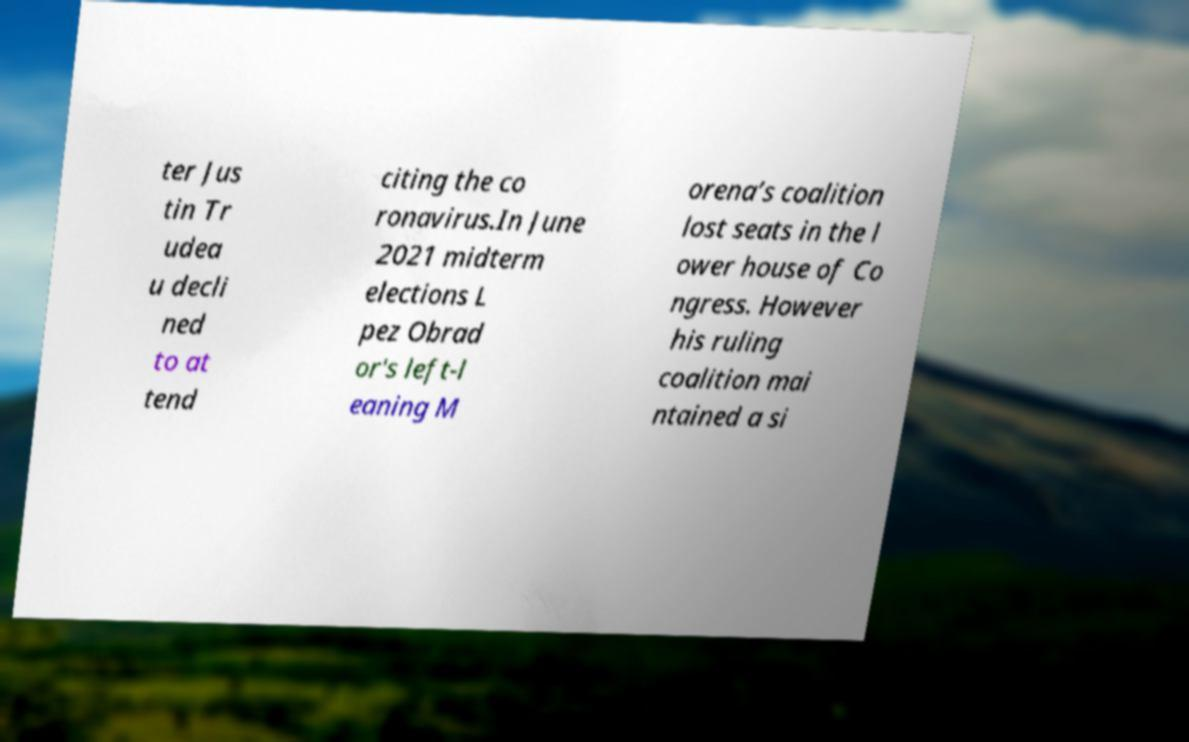For documentation purposes, I need the text within this image transcribed. Could you provide that? ter Jus tin Tr udea u decli ned to at tend citing the co ronavirus.In June 2021 midterm elections L pez Obrad or's left-l eaning M orena’s coalition lost seats in the l ower house of Co ngress. However his ruling coalition mai ntained a si 